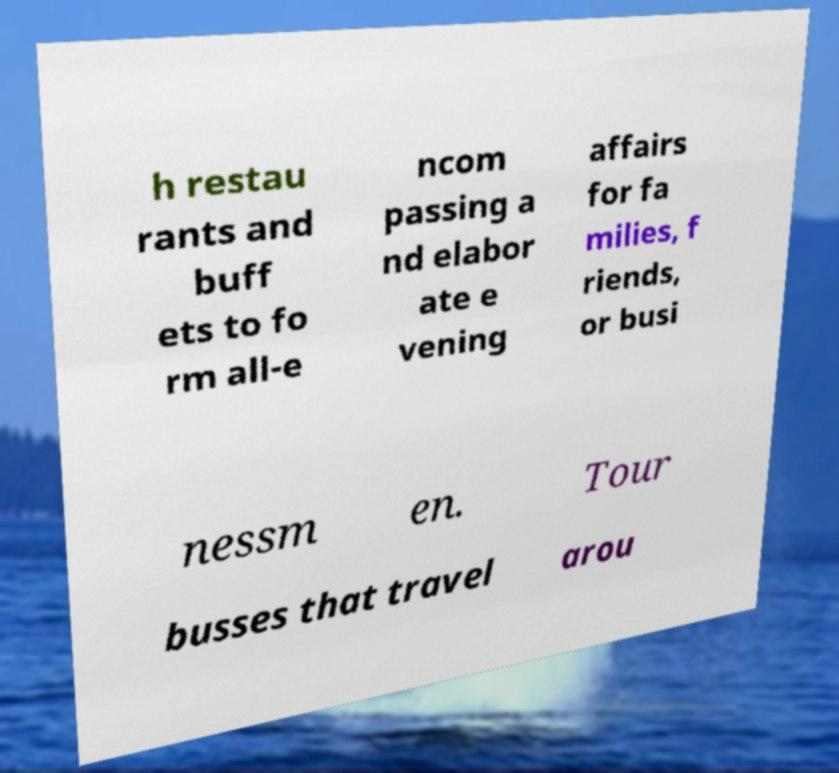Could you assist in decoding the text presented in this image and type it out clearly? h restau rants and buff ets to fo rm all-e ncom passing a nd elabor ate e vening affairs for fa milies, f riends, or busi nessm en. Tour busses that travel arou 